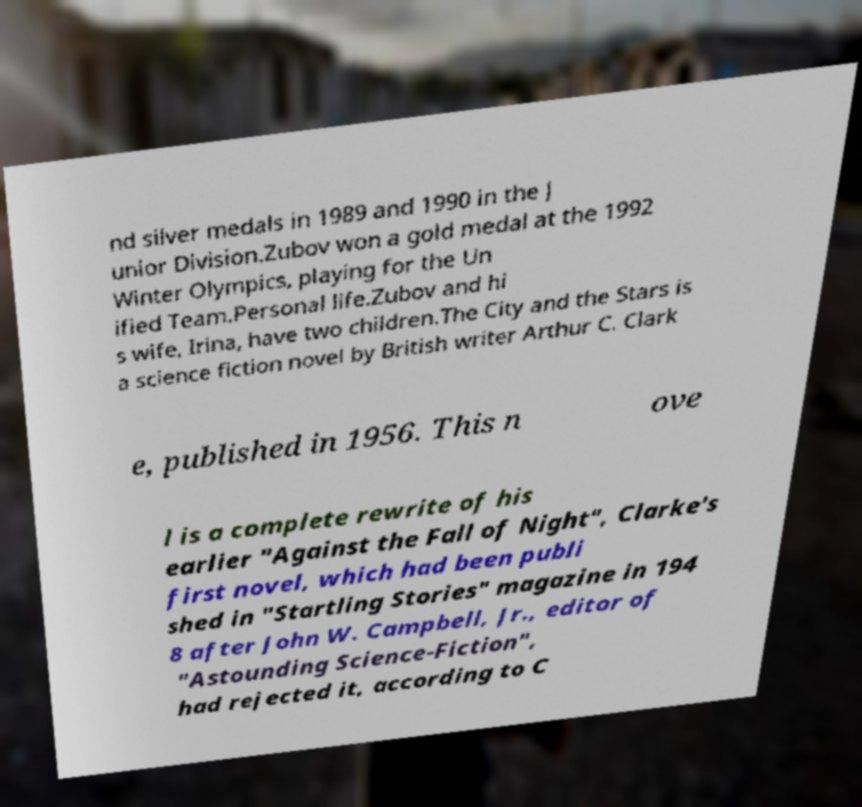Could you extract and type out the text from this image? nd silver medals in 1989 and 1990 in the J unior Division.Zubov won a gold medal at the 1992 Winter Olympics, playing for the Un ified Team.Personal life.Zubov and hi s wife, Irina, have two children.The City and the Stars is a science fiction novel by British writer Arthur C. Clark e, published in 1956. This n ove l is a complete rewrite of his earlier "Against the Fall of Night", Clarke's first novel, which had been publi shed in "Startling Stories" magazine in 194 8 after John W. Campbell, Jr., editor of "Astounding Science-Fiction", had rejected it, according to C 